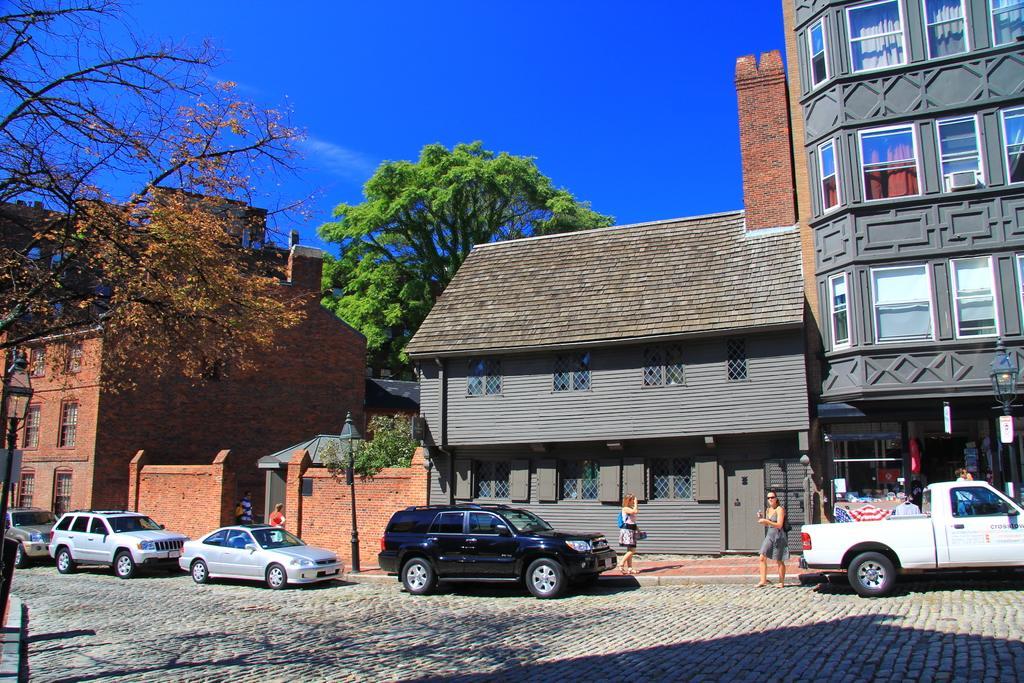Can you describe this image briefly? There are vehicles on the road. Here we can see few persons. There are trees, houses, poles, boards, and a building. In the background there is sky. 